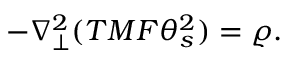<formula> <loc_0><loc_0><loc_500><loc_500>- \nabla _ { \perp } ^ { 2 } ( T M F \theta _ { s } ^ { 2 } ) = \varrho .</formula> 